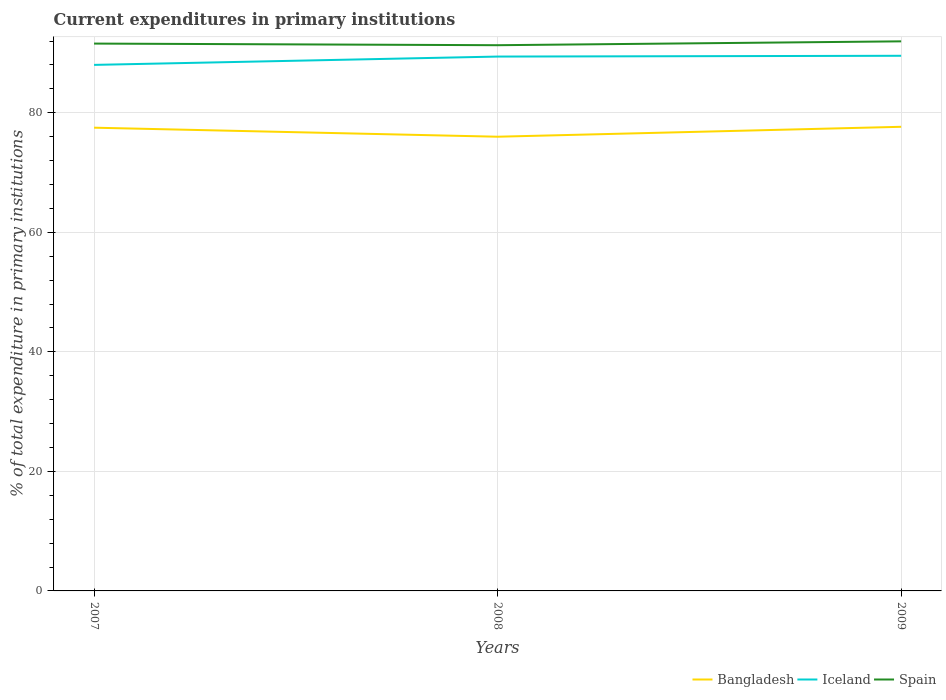Across all years, what is the maximum current expenditures in primary institutions in Spain?
Your response must be concise. 91.3. In which year was the current expenditures in primary institutions in Spain maximum?
Give a very brief answer. 2008. What is the total current expenditures in primary institutions in Bangladesh in the graph?
Ensure brevity in your answer.  -0.15. What is the difference between the highest and the second highest current expenditures in primary institutions in Iceland?
Ensure brevity in your answer.  1.53. What is the difference between the highest and the lowest current expenditures in primary institutions in Iceland?
Offer a terse response. 2. Is the current expenditures in primary institutions in Bangladesh strictly greater than the current expenditures in primary institutions in Spain over the years?
Keep it short and to the point. Yes. How many years are there in the graph?
Your answer should be very brief. 3. What is the difference between two consecutive major ticks on the Y-axis?
Ensure brevity in your answer.  20. Does the graph contain any zero values?
Provide a short and direct response. No. Does the graph contain grids?
Make the answer very short. Yes. What is the title of the graph?
Your response must be concise. Current expenditures in primary institutions. What is the label or title of the Y-axis?
Ensure brevity in your answer.  % of total expenditure in primary institutions. What is the % of total expenditure in primary institutions of Bangladesh in 2007?
Offer a terse response. 77.5. What is the % of total expenditure in primary institutions of Iceland in 2007?
Provide a short and direct response. 88. What is the % of total expenditure in primary institutions in Spain in 2007?
Your answer should be very brief. 91.57. What is the % of total expenditure in primary institutions in Bangladesh in 2008?
Give a very brief answer. 75.99. What is the % of total expenditure in primary institutions in Iceland in 2008?
Your answer should be compact. 89.4. What is the % of total expenditure in primary institutions of Spain in 2008?
Give a very brief answer. 91.3. What is the % of total expenditure in primary institutions of Bangladesh in 2009?
Provide a succinct answer. 77.65. What is the % of total expenditure in primary institutions in Iceland in 2009?
Ensure brevity in your answer.  89.53. What is the % of total expenditure in primary institutions in Spain in 2009?
Offer a terse response. 91.94. Across all years, what is the maximum % of total expenditure in primary institutions in Bangladesh?
Give a very brief answer. 77.65. Across all years, what is the maximum % of total expenditure in primary institutions of Iceland?
Offer a very short reply. 89.53. Across all years, what is the maximum % of total expenditure in primary institutions in Spain?
Your answer should be very brief. 91.94. Across all years, what is the minimum % of total expenditure in primary institutions in Bangladesh?
Offer a very short reply. 75.99. Across all years, what is the minimum % of total expenditure in primary institutions in Iceland?
Make the answer very short. 88. Across all years, what is the minimum % of total expenditure in primary institutions in Spain?
Your response must be concise. 91.3. What is the total % of total expenditure in primary institutions of Bangladesh in the graph?
Keep it short and to the point. 231.13. What is the total % of total expenditure in primary institutions in Iceland in the graph?
Give a very brief answer. 266.93. What is the total % of total expenditure in primary institutions of Spain in the graph?
Your answer should be compact. 274.81. What is the difference between the % of total expenditure in primary institutions of Bangladesh in 2007 and that in 2008?
Offer a very short reply. 1.51. What is the difference between the % of total expenditure in primary institutions in Iceland in 2007 and that in 2008?
Keep it short and to the point. -1.39. What is the difference between the % of total expenditure in primary institutions of Spain in 2007 and that in 2008?
Keep it short and to the point. 0.27. What is the difference between the % of total expenditure in primary institutions of Bangladesh in 2007 and that in 2009?
Your answer should be very brief. -0.15. What is the difference between the % of total expenditure in primary institutions of Iceland in 2007 and that in 2009?
Provide a short and direct response. -1.53. What is the difference between the % of total expenditure in primary institutions in Spain in 2007 and that in 2009?
Keep it short and to the point. -0.37. What is the difference between the % of total expenditure in primary institutions in Bangladesh in 2008 and that in 2009?
Offer a very short reply. -1.66. What is the difference between the % of total expenditure in primary institutions of Iceland in 2008 and that in 2009?
Provide a short and direct response. -0.13. What is the difference between the % of total expenditure in primary institutions in Spain in 2008 and that in 2009?
Provide a succinct answer. -0.65. What is the difference between the % of total expenditure in primary institutions of Bangladesh in 2007 and the % of total expenditure in primary institutions of Iceland in 2008?
Give a very brief answer. -11.9. What is the difference between the % of total expenditure in primary institutions of Bangladesh in 2007 and the % of total expenditure in primary institutions of Spain in 2008?
Provide a short and direct response. -13.8. What is the difference between the % of total expenditure in primary institutions in Iceland in 2007 and the % of total expenditure in primary institutions in Spain in 2008?
Your response must be concise. -3.29. What is the difference between the % of total expenditure in primary institutions in Bangladesh in 2007 and the % of total expenditure in primary institutions in Iceland in 2009?
Your answer should be compact. -12.03. What is the difference between the % of total expenditure in primary institutions of Bangladesh in 2007 and the % of total expenditure in primary institutions of Spain in 2009?
Give a very brief answer. -14.45. What is the difference between the % of total expenditure in primary institutions in Iceland in 2007 and the % of total expenditure in primary institutions in Spain in 2009?
Keep it short and to the point. -3.94. What is the difference between the % of total expenditure in primary institutions in Bangladesh in 2008 and the % of total expenditure in primary institutions in Iceland in 2009?
Your answer should be very brief. -13.54. What is the difference between the % of total expenditure in primary institutions in Bangladesh in 2008 and the % of total expenditure in primary institutions in Spain in 2009?
Ensure brevity in your answer.  -15.96. What is the difference between the % of total expenditure in primary institutions in Iceland in 2008 and the % of total expenditure in primary institutions in Spain in 2009?
Your response must be concise. -2.55. What is the average % of total expenditure in primary institutions of Bangladesh per year?
Keep it short and to the point. 77.04. What is the average % of total expenditure in primary institutions in Iceland per year?
Ensure brevity in your answer.  88.98. What is the average % of total expenditure in primary institutions in Spain per year?
Keep it short and to the point. 91.6. In the year 2007, what is the difference between the % of total expenditure in primary institutions in Bangladesh and % of total expenditure in primary institutions in Iceland?
Provide a succinct answer. -10.51. In the year 2007, what is the difference between the % of total expenditure in primary institutions in Bangladesh and % of total expenditure in primary institutions in Spain?
Your answer should be compact. -14.07. In the year 2007, what is the difference between the % of total expenditure in primary institutions of Iceland and % of total expenditure in primary institutions of Spain?
Your answer should be compact. -3.57. In the year 2008, what is the difference between the % of total expenditure in primary institutions of Bangladesh and % of total expenditure in primary institutions of Iceland?
Offer a very short reply. -13.41. In the year 2008, what is the difference between the % of total expenditure in primary institutions of Bangladesh and % of total expenditure in primary institutions of Spain?
Provide a short and direct response. -15.31. In the year 2008, what is the difference between the % of total expenditure in primary institutions of Iceland and % of total expenditure in primary institutions of Spain?
Offer a very short reply. -1.9. In the year 2009, what is the difference between the % of total expenditure in primary institutions in Bangladesh and % of total expenditure in primary institutions in Iceland?
Offer a very short reply. -11.88. In the year 2009, what is the difference between the % of total expenditure in primary institutions in Bangladesh and % of total expenditure in primary institutions in Spain?
Make the answer very short. -14.3. In the year 2009, what is the difference between the % of total expenditure in primary institutions of Iceland and % of total expenditure in primary institutions of Spain?
Provide a short and direct response. -2.41. What is the ratio of the % of total expenditure in primary institutions of Bangladesh in 2007 to that in 2008?
Give a very brief answer. 1.02. What is the ratio of the % of total expenditure in primary institutions in Iceland in 2007 to that in 2008?
Offer a terse response. 0.98. What is the ratio of the % of total expenditure in primary institutions of Spain in 2007 to that in 2008?
Your answer should be very brief. 1. What is the ratio of the % of total expenditure in primary institutions of Bangladesh in 2007 to that in 2009?
Make the answer very short. 1. What is the ratio of the % of total expenditure in primary institutions in Iceland in 2007 to that in 2009?
Give a very brief answer. 0.98. What is the ratio of the % of total expenditure in primary institutions in Spain in 2007 to that in 2009?
Provide a succinct answer. 1. What is the ratio of the % of total expenditure in primary institutions in Bangladesh in 2008 to that in 2009?
Ensure brevity in your answer.  0.98. What is the ratio of the % of total expenditure in primary institutions of Iceland in 2008 to that in 2009?
Offer a very short reply. 1. What is the ratio of the % of total expenditure in primary institutions in Spain in 2008 to that in 2009?
Make the answer very short. 0.99. What is the difference between the highest and the second highest % of total expenditure in primary institutions in Bangladesh?
Offer a very short reply. 0.15. What is the difference between the highest and the second highest % of total expenditure in primary institutions in Iceland?
Your answer should be compact. 0.13. What is the difference between the highest and the second highest % of total expenditure in primary institutions of Spain?
Offer a terse response. 0.37. What is the difference between the highest and the lowest % of total expenditure in primary institutions in Bangladesh?
Give a very brief answer. 1.66. What is the difference between the highest and the lowest % of total expenditure in primary institutions of Iceland?
Ensure brevity in your answer.  1.53. What is the difference between the highest and the lowest % of total expenditure in primary institutions in Spain?
Your response must be concise. 0.65. 